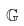Convert formula to latex. <formula><loc_0><loc_0><loc_500><loc_500>\mathbb { G }</formula> 